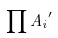Convert formula to latex. <formula><loc_0><loc_0><loc_500><loc_500>\prod { A _ { i } } ^ { \prime }</formula> 